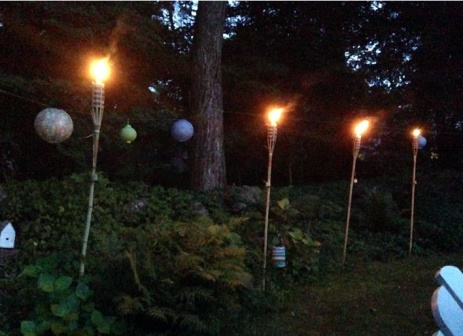What's happening in the scene? The image captures a serene night scene in a garden illuminated by six tiki torches that are burning bright, their flames casting a warm, flickering glow over the surroundings. These torches are arranged in two groups of three, positioned on the left and right sides of the scene, adding symmetry and charm to the view. The garden itself is a lush sanctuary, teeming with a variety of plants, notably vibrant ferns and hostas that thrive in the dim light. Further enhancing the magical ambiance, three paper lanterns hang from the trees. These lanterns, two white and one green, emit a soft, muted light that adds to the tranquility. The image is taken from a low angle, thoughtfully guiding the viewer's gaze upwards along the lines of the torches and lanterns to the canopy of trees above. Overall, the composition skillfully blends the elements of light and nature, evoking a sense of peace and quiet reflection under the night sky, making it a perfect retreat. 